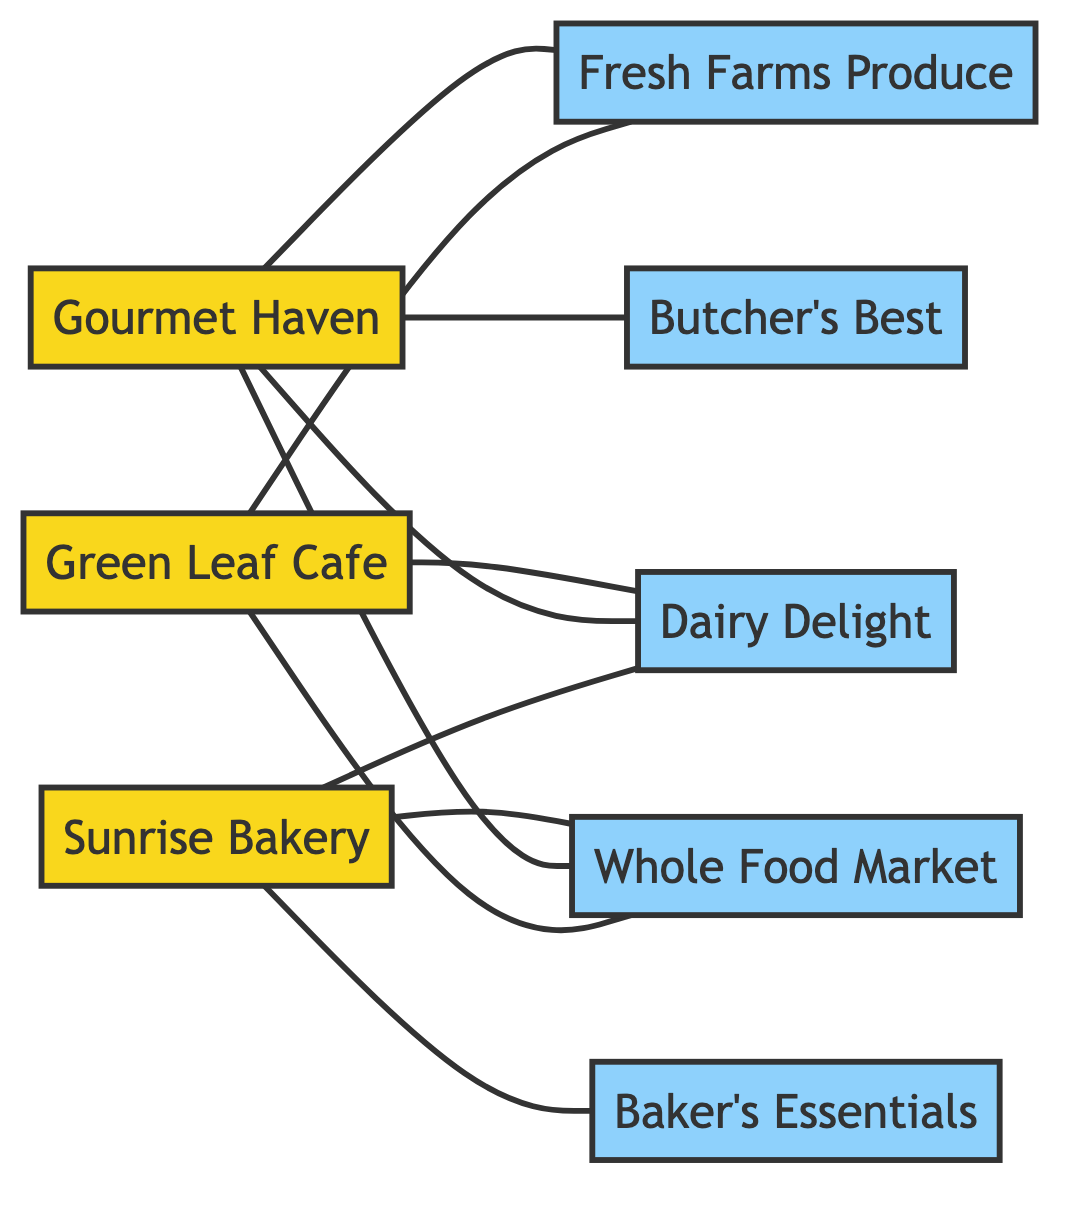What is the total number of nodes in the diagram? By counting the nodes listed, we have 8 entities: Gourmet Haven, Sunrise Bakery, Green Leaf Cafe, Fresh Farms Produce, Butcher's Best, Dairy Delight, Baker's Essentials, and Whole Food Market. Thus, the total count is 8.
Answer: 8 Which business is connected to the Dairy Supplier? The diagram shows that both Green Leaf Cafe and Gourmet Haven (Restaurant) are connected to Dairy Delight (Dairy Supplier).
Answer: Green Leaf Cafe, Gourmet Haven How many edges connect the Restaurant to suppliers? The Restaurant, Gourmet Haven, is connected to three suppliers: Fresh Farms Produce, Butcher's Best, and Dairy Delight. Thus, there are 3 edges connecting them.
Answer: 3 Which business exclusively uses the BakerySupplier? Sunrise Bakery is the only business that has a connection with Bakery's Essentials (BakerySupplier) and no other business is connected to it.
Answer: Sunrise Bakery From which supplier does the Green Leaf Cafe receive ingredients? The Green Leaf Cafe is connected to three suppliers: Dairy Delight, Fresh Farms Produce, and Whole Food Market. Therefore, it receives ingredients from these three suppliers.
Answer: Dairy Delight, Fresh Farms Produce, Whole Food Market Which supplier serves the most businesses in the diagram? By analyzing the connections, the GrocerySupplier (Whole Food Market) connects with three businesses: Gourmet Haven, Sunrise Bakery, and Green Leaf Cafe. Hence, it serves the most businesses in the diagram.
Answer: Whole Food Market What type of supplier connects both Bakery and Green Leaf Cafe? Fresh Farms Produce (VegetableSupplier) is the supplier connected to both Sunrise Bakery and Green Leaf Cafe.
Answer: Fresh Farms Produce How many total edges are there in the diagram? By listing all connections (edges), we find there are 10 edges in total connecting the businesses to their respective suppliers.
Answer: 10 Which business shares a supply connection with the most others? Gourmet Haven (Restaurant) shares connections with three different suppliers and is linked to three businesses. Overall, it has connections with a total of 6 entities in the network, making it the most interconnected business.
Answer: Gourmet Haven 